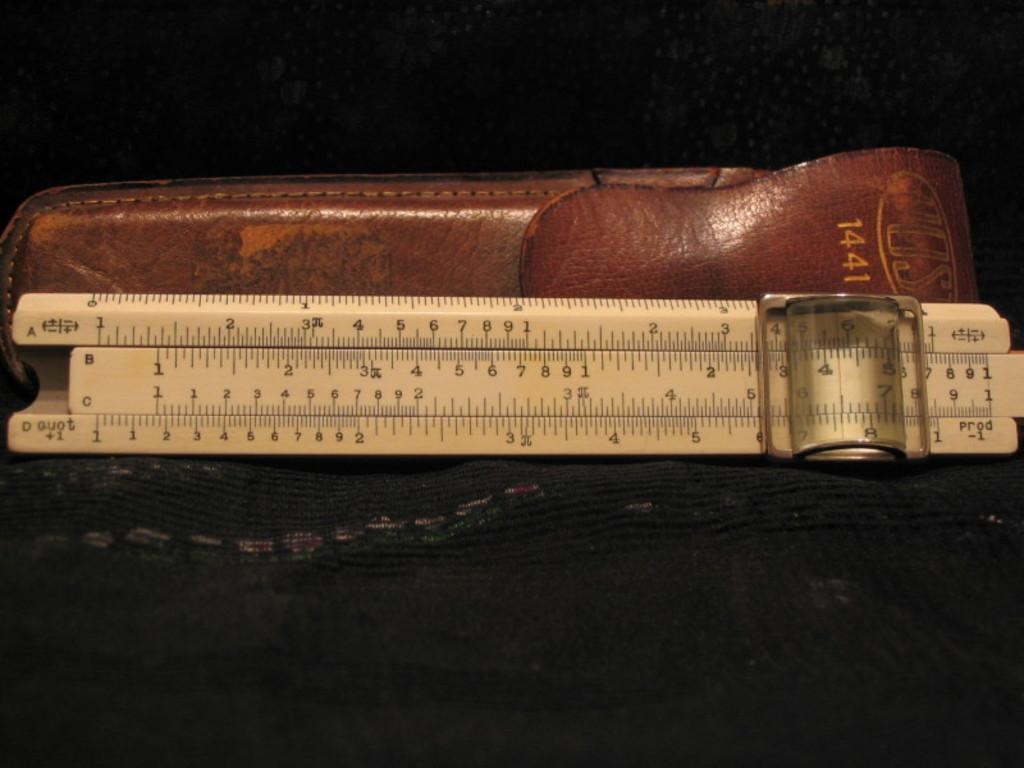<image>
Present a compact description of the photo's key features. A leather cover with 1441 embossed on the flap. 